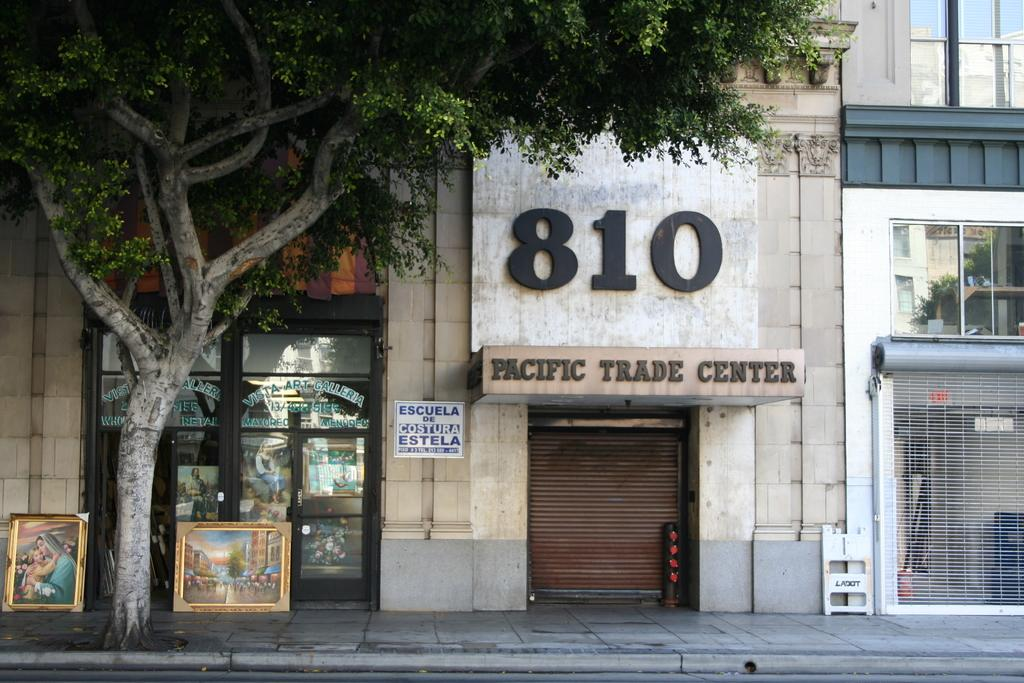What type of structure is visible in the image? There is a building in the image. What feature can be observed on the building? The building has glass windows. What decorations are present on the building and windows? There are posters on the wall and glass windows. What is located in front of the building? There is a tree and pictures in front of the building. How many clocks can be seen hanging on the tree in front of the building? There are no clocks visible on the tree in front of the building. What type of liquid is dripping from the mask on the glass window? There is no mask present on the glass window in the image. 